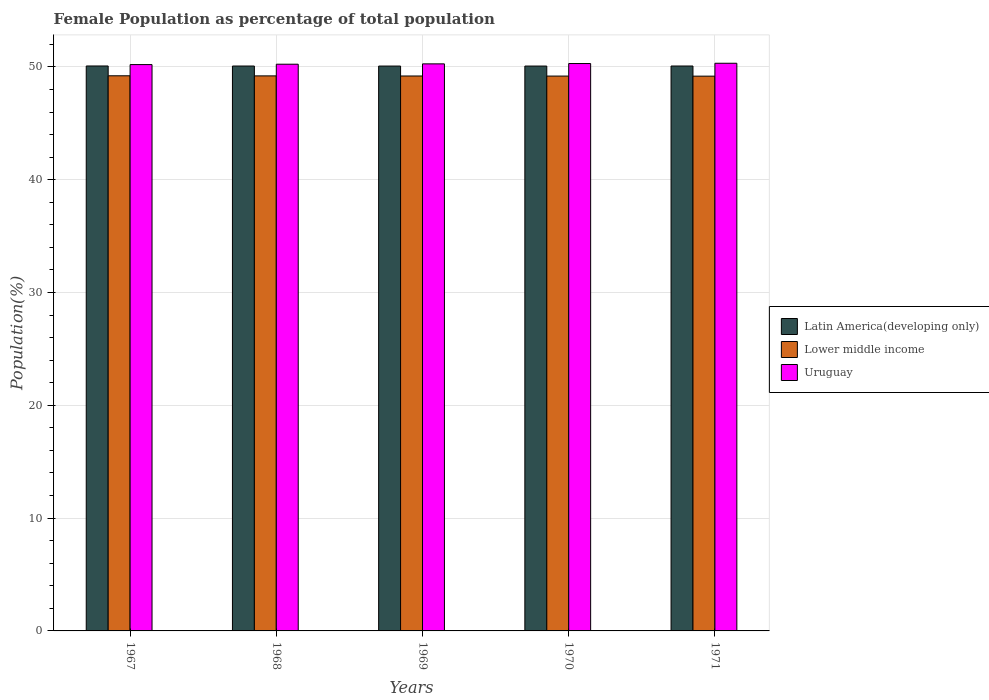How many groups of bars are there?
Keep it short and to the point. 5. Are the number of bars per tick equal to the number of legend labels?
Offer a terse response. Yes. What is the label of the 3rd group of bars from the left?
Provide a short and direct response. 1969. What is the female population in in Uruguay in 1971?
Keep it short and to the point. 50.32. Across all years, what is the maximum female population in in Lower middle income?
Give a very brief answer. 49.21. Across all years, what is the minimum female population in in Uruguay?
Your answer should be very brief. 50.2. In which year was the female population in in Latin America(developing only) maximum?
Give a very brief answer. 1967. In which year was the female population in in Uruguay minimum?
Provide a short and direct response. 1967. What is the total female population in in Lower middle income in the graph?
Offer a terse response. 245.97. What is the difference between the female population in in Uruguay in 1968 and that in 1970?
Your response must be concise. -0.06. What is the difference between the female population in in Lower middle income in 1971 and the female population in in Uruguay in 1967?
Your answer should be very brief. -1.03. What is the average female population in in Uruguay per year?
Your response must be concise. 50.26. In the year 1970, what is the difference between the female population in in Uruguay and female population in in Lower middle income?
Make the answer very short. 1.11. What is the ratio of the female population in in Uruguay in 1968 to that in 1970?
Offer a very short reply. 1. What is the difference between the highest and the second highest female population in in Uruguay?
Give a very brief answer. 0.03. What is the difference between the highest and the lowest female population in in Latin America(developing only)?
Keep it short and to the point. 0.01. In how many years, is the female population in in Latin America(developing only) greater than the average female population in in Latin America(developing only) taken over all years?
Provide a succinct answer. 2. What does the 2nd bar from the left in 1970 represents?
Give a very brief answer. Lower middle income. What does the 3rd bar from the right in 1967 represents?
Your response must be concise. Latin America(developing only). Is it the case that in every year, the sum of the female population in in Latin America(developing only) and female population in in Lower middle income is greater than the female population in in Uruguay?
Your answer should be very brief. Yes. What is the difference between two consecutive major ticks on the Y-axis?
Your answer should be compact. 10. Does the graph contain any zero values?
Make the answer very short. No. Does the graph contain grids?
Keep it short and to the point. Yes. How are the legend labels stacked?
Provide a succinct answer. Vertical. What is the title of the graph?
Ensure brevity in your answer.  Female Population as percentage of total population. Does "Latin America(all income levels)" appear as one of the legend labels in the graph?
Your answer should be compact. No. What is the label or title of the X-axis?
Your answer should be very brief. Years. What is the label or title of the Y-axis?
Provide a short and direct response. Population(%). What is the Population(%) in Latin America(developing only) in 1967?
Your answer should be very brief. 50.08. What is the Population(%) in Lower middle income in 1967?
Ensure brevity in your answer.  49.21. What is the Population(%) in Uruguay in 1967?
Keep it short and to the point. 50.2. What is the Population(%) of Latin America(developing only) in 1968?
Offer a terse response. 50.08. What is the Population(%) of Lower middle income in 1968?
Your answer should be very brief. 49.2. What is the Population(%) of Uruguay in 1968?
Make the answer very short. 50.24. What is the Population(%) of Latin America(developing only) in 1969?
Offer a very short reply. 50.07. What is the Population(%) of Lower middle income in 1969?
Give a very brief answer. 49.19. What is the Population(%) of Uruguay in 1969?
Give a very brief answer. 50.27. What is the Population(%) in Latin America(developing only) in 1970?
Keep it short and to the point. 50.07. What is the Population(%) in Lower middle income in 1970?
Keep it short and to the point. 49.18. What is the Population(%) of Uruguay in 1970?
Offer a very short reply. 50.3. What is the Population(%) of Latin America(developing only) in 1971?
Your answer should be very brief. 50.08. What is the Population(%) of Lower middle income in 1971?
Your answer should be compact. 49.18. What is the Population(%) in Uruguay in 1971?
Offer a very short reply. 50.32. Across all years, what is the maximum Population(%) in Latin America(developing only)?
Provide a succinct answer. 50.08. Across all years, what is the maximum Population(%) of Lower middle income?
Your response must be concise. 49.21. Across all years, what is the maximum Population(%) of Uruguay?
Offer a terse response. 50.32. Across all years, what is the minimum Population(%) in Latin America(developing only)?
Ensure brevity in your answer.  50.07. Across all years, what is the minimum Population(%) in Lower middle income?
Offer a very short reply. 49.18. Across all years, what is the minimum Population(%) of Uruguay?
Provide a short and direct response. 50.2. What is the total Population(%) in Latin America(developing only) in the graph?
Offer a very short reply. 250.38. What is the total Population(%) in Lower middle income in the graph?
Provide a succinct answer. 245.97. What is the total Population(%) of Uruguay in the graph?
Your response must be concise. 251.32. What is the difference between the Population(%) in Latin America(developing only) in 1967 and that in 1968?
Ensure brevity in your answer.  0. What is the difference between the Population(%) of Lower middle income in 1967 and that in 1968?
Provide a succinct answer. 0.01. What is the difference between the Population(%) of Uruguay in 1967 and that in 1968?
Your response must be concise. -0.03. What is the difference between the Population(%) of Latin America(developing only) in 1967 and that in 1969?
Provide a short and direct response. 0.01. What is the difference between the Population(%) in Lower middle income in 1967 and that in 1969?
Ensure brevity in your answer.  0.02. What is the difference between the Population(%) in Uruguay in 1967 and that in 1969?
Keep it short and to the point. -0.06. What is the difference between the Population(%) in Latin America(developing only) in 1967 and that in 1970?
Offer a very short reply. 0.01. What is the difference between the Population(%) of Lower middle income in 1967 and that in 1970?
Your answer should be compact. 0.03. What is the difference between the Population(%) of Uruguay in 1967 and that in 1970?
Keep it short and to the point. -0.09. What is the difference between the Population(%) of Latin America(developing only) in 1967 and that in 1971?
Your answer should be very brief. 0. What is the difference between the Population(%) of Lower middle income in 1967 and that in 1971?
Make the answer very short. 0.03. What is the difference between the Population(%) in Uruguay in 1967 and that in 1971?
Your response must be concise. -0.12. What is the difference between the Population(%) of Latin America(developing only) in 1968 and that in 1969?
Offer a terse response. 0. What is the difference between the Population(%) in Lower middle income in 1968 and that in 1969?
Offer a very short reply. 0.01. What is the difference between the Population(%) of Uruguay in 1968 and that in 1969?
Offer a very short reply. -0.03. What is the difference between the Population(%) of Latin America(developing only) in 1968 and that in 1970?
Your answer should be compact. 0. What is the difference between the Population(%) of Lower middle income in 1968 and that in 1970?
Keep it short and to the point. 0.02. What is the difference between the Population(%) in Uruguay in 1968 and that in 1970?
Provide a succinct answer. -0.06. What is the difference between the Population(%) of Latin America(developing only) in 1968 and that in 1971?
Provide a succinct answer. -0. What is the difference between the Population(%) in Lower middle income in 1968 and that in 1971?
Ensure brevity in your answer.  0.02. What is the difference between the Population(%) of Uruguay in 1968 and that in 1971?
Your response must be concise. -0.08. What is the difference between the Population(%) in Latin America(developing only) in 1969 and that in 1970?
Ensure brevity in your answer.  -0. What is the difference between the Population(%) in Lower middle income in 1969 and that in 1970?
Ensure brevity in your answer.  0.01. What is the difference between the Population(%) in Uruguay in 1969 and that in 1970?
Keep it short and to the point. -0.03. What is the difference between the Population(%) of Latin America(developing only) in 1969 and that in 1971?
Keep it short and to the point. -0. What is the difference between the Population(%) of Lower middle income in 1969 and that in 1971?
Offer a very short reply. 0.01. What is the difference between the Population(%) of Uruguay in 1969 and that in 1971?
Your response must be concise. -0.05. What is the difference between the Population(%) in Latin America(developing only) in 1970 and that in 1971?
Your answer should be very brief. -0. What is the difference between the Population(%) of Lower middle income in 1970 and that in 1971?
Your answer should be very brief. 0.01. What is the difference between the Population(%) of Uruguay in 1970 and that in 1971?
Your answer should be very brief. -0.03. What is the difference between the Population(%) of Latin America(developing only) in 1967 and the Population(%) of Lower middle income in 1968?
Provide a succinct answer. 0.88. What is the difference between the Population(%) in Latin America(developing only) in 1967 and the Population(%) in Uruguay in 1968?
Make the answer very short. -0.16. What is the difference between the Population(%) of Lower middle income in 1967 and the Population(%) of Uruguay in 1968?
Provide a succinct answer. -1.03. What is the difference between the Population(%) of Latin America(developing only) in 1967 and the Population(%) of Lower middle income in 1969?
Provide a succinct answer. 0.89. What is the difference between the Population(%) in Latin America(developing only) in 1967 and the Population(%) in Uruguay in 1969?
Give a very brief answer. -0.19. What is the difference between the Population(%) of Lower middle income in 1967 and the Population(%) of Uruguay in 1969?
Ensure brevity in your answer.  -1.06. What is the difference between the Population(%) of Latin America(developing only) in 1967 and the Population(%) of Lower middle income in 1970?
Provide a succinct answer. 0.9. What is the difference between the Population(%) in Latin America(developing only) in 1967 and the Population(%) in Uruguay in 1970?
Your response must be concise. -0.22. What is the difference between the Population(%) of Lower middle income in 1967 and the Population(%) of Uruguay in 1970?
Make the answer very short. -1.08. What is the difference between the Population(%) of Latin America(developing only) in 1967 and the Population(%) of Lower middle income in 1971?
Make the answer very short. 0.9. What is the difference between the Population(%) of Latin America(developing only) in 1967 and the Population(%) of Uruguay in 1971?
Keep it short and to the point. -0.24. What is the difference between the Population(%) of Lower middle income in 1967 and the Population(%) of Uruguay in 1971?
Ensure brevity in your answer.  -1.11. What is the difference between the Population(%) in Latin America(developing only) in 1968 and the Population(%) in Lower middle income in 1969?
Your response must be concise. 0.88. What is the difference between the Population(%) of Latin America(developing only) in 1968 and the Population(%) of Uruguay in 1969?
Offer a very short reply. -0.19. What is the difference between the Population(%) in Lower middle income in 1968 and the Population(%) in Uruguay in 1969?
Keep it short and to the point. -1.07. What is the difference between the Population(%) in Latin America(developing only) in 1968 and the Population(%) in Lower middle income in 1970?
Provide a succinct answer. 0.89. What is the difference between the Population(%) in Latin America(developing only) in 1968 and the Population(%) in Uruguay in 1970?
Provide a succinct answer. -0.22. What is the difference between the Population(%) of Lower middle income in 1968 and the Population(%) of Uruguay in 1970?
Make the answer very short. -1.09. What is the difference between the Population(%) in Latin America(developing only) in 1968 and the Population(%) in Lower middle income in 1971?
Ensure brevity in your answer.  0.9. What is the difference between the Population(%) in Latin America(developing only) in 1968 and the Population(%) in Uruguay in 1971?
Ensure brevity in your answer.  -0.25. What is the difference between the Population(%) of Lower middle income in 1968 and the Population(%) of Uruguay in 1971?
Offer a very short reply. -1.12. What is the difference between the Population(%) in Latin America(developing only) in 1969 and the Population(%) in Lower middle income in 1970?
Offer a terse response. 0.89. What is the difference between the Population(%) in Latin America(developing only) in 1969 and the Population(%) in Uruguay in 1970?
Provide a succinct answer. -0.22. What is the difference between the Population(%) in Lower middle income in 1969 and the Population(%) in Uruguay in 1970?
Your answer should be very brief. -1.1. What is the difference between the Population(%) of Latin America(developing only) in 1969 and the Population(%) of Lower middle income in 1971?
Provide a short and direct response. 0.9. What is the difference between the Population(%) in Latin America(developing only) in 1969 and the Population(%) in Uruguay in 1971?
Provide a succinct answer. -0.25. What is the difference between the Population(%) of Lower middle income in 1969 and the Population(%) of Uruguay in 1971?
Give a very brief answer. -1.13. What is the difference between the Population(%) of Latin America(developing only) in 1970 and the Population(%) of Lower middle income in 1971?
Keep it short and to the point. 0.9. What is the difference between the Population(%) of Latin America(developing only) in 1970 and the Population(%) of Uruguay in 1971?
Provide a succinct answer. -0.25. What is the difference between the Population(%) of Lower middle income in 1970 and the Population(%) of Uruguay in 1971?
Your response must be concise. -1.14. What is the average Population(%) in Latin America(developing only) per year?
Make the answer very short. 50.08. What is the average Population(%) of Lower middle income per year?
Provide a short and direct response. 49.19. What is the average Population(%) in Uruguay per year?
Provide a short and direct response. 50.26. In the year 1967, what is the difference between the Population(%) of Latin America(developing only) and Population(%) of Lower middle income?
Make the answer very short. 0.87. In the year 1967, what is the difference between the Population(%) of Latin America(developing only) and Population(%) of Uruguay?
Your answer should be compact. -0.12. In the year 1967, what is the difference between the Population(%) of Lower middle income and Population(%) of Uruguay?
Keep it short and to the point. -0.99. In the year 1968, what is the difference between the Population(%) of Latin America(developing only) and Population(%) of Lower middle income?
Give a very brief answer. 0.87. In the year 1968, what is the difference between the Population(%) of Latin America(developing only) and Population(%) of Uruguay?
Your answer should be compact. -0.16. In the year 1968, what is the difference between the Population(%) in Lower middle income and Population(%) in Uruguay?
Your answer should be compact. -1.03. In the year 1969, what is the difference between the Population(%) in Latin America(developing only) and Population(%) in Lower middle income?
Provide a short and direct response. 0.88. In the year 1969, what is the difference between the Population(%) in Latin America(developing only) and Population(%) in Uruguay?
Your response must be concise. -0.19. In the year 1969, what is the difference between the Population(%) of Lower middle income and Population(%) of Uruguay?
Your answer should be very brief. -1.07. In the year 1970, what is the difference between the Population(%) of Latin America(developing only) and Population(%) of Lower middle income?
Offer a terse response. 0.89. In the year 1970, what is the difference between the Population(%) of Latin America(developing only) and Population(%) of Uruguay?
Keep it short and to the point. -0.22. In the year 1970, what is the difference between the Population(%) in Lower middle income and Population(%) in Uruguay?
Your response must be concise. -1.11. In the year 1971, what is the difference between the Population(%) of Latin America(developing only) and Population(%) of Lower middle income?
Make the answer very short. 0.9. In the year 1971, what is the difference between the Population(%) in Latin America(developing only) and Population(%) in Uruguay?
Give a very brief answer. -0.24. In the year 1971, what is the difference between the Population(%) of Lower middle income and Population(%) of Uruguay?
Give a very brief answer. -1.14. What is the ratio of the Population(%) of Lower middle income in 1967 to that in 1968?
Ensure brevity in your answer.  1. What is the ratio of the Population(%) of Uruguay in 1967 to that in 1969?
Make the answer very short. 1. What is the ratio of the Population(%) of Uruguay in 1967 to that in 1970?
Your answer should be very brief. 1. What is the ratio of the Population(%) in Latin America(developing only) in 1967 to that in 1971?
Your answer should be very brief. 1. What is the ratio of the Population(%) of Lower middle income in 1968 to that in 1969?
Provide a succinct answer. 1. What is the ratio of the Population(%) of Lower middle income in 1968 to that in 1970?
Keep it short and to the point. 1. What is the ratio of the Population(%) in Uruguay in 1968 to that in 1970?
Keep it short and to the point. 1. What is the ratio of the Population(%) in Latin America(developing only) in 1968 to that in 1971?
Make the answer very short. 1. What is the ratio of the Population(%) in Lower middle income in 1968 to that in 1971?
Provide a succinct answer. 1. What is the ratio of the Population(%) of Uruguay in 1968 to that in 1971?
Make the answer very short. 1. What is the ratio of the Population(%) in Latin America(developing only) in 1969 to that in 1970?
Make the answer very short. 1. What is the ratio of the Population(%) in Lower middle income in 1969 to that in 1970?
Your answer should be very brief. 1. What is the ratio of the Population(%) of Uruguay in 1969 to that in 1970?
Provide a short and direct response. 1. What is the ratio of the Population(%) in Latin America(developing only) in 1969 to that in 1971?
Ensure brevity in your answer.  1. What is the ratio of the Population(%) in Lower middle income in 1969 to that in 1971?
Provide a short and direct response. 1. What is the ratio of the Population(%) of Latin America(developing only) in 1970 to that in 1971?
Provide a succinct answer. 1. What is the ratio of the Population(%) of Lower middle income in 1970 to that in 1971?
Make the answer very short. 1. What is the difference between the highest and the second highest Population(%) of Latin America(developing only)?
Give a very brief answer. 0. What is the difference between the highest and the second highest Population(%) in Lower middle income?
Offer a terse response. 0.01. What is the difference between the highest and the second highest Population(%) of Uruguay?
Ensure brevity in your answer.  0.03. What is the difference between the highest and the lowest Population(%) of Latin America(developing only)?
Provide a succinct answer. 0.01. What is the difference between the highest and the lowest Population(%) in Lower middle income?
Provide a short and direct response. 0.03. What is the difference between the highest and the lowest Population(%) of Uruguay?
Provide a short and direct response. 0.12. 